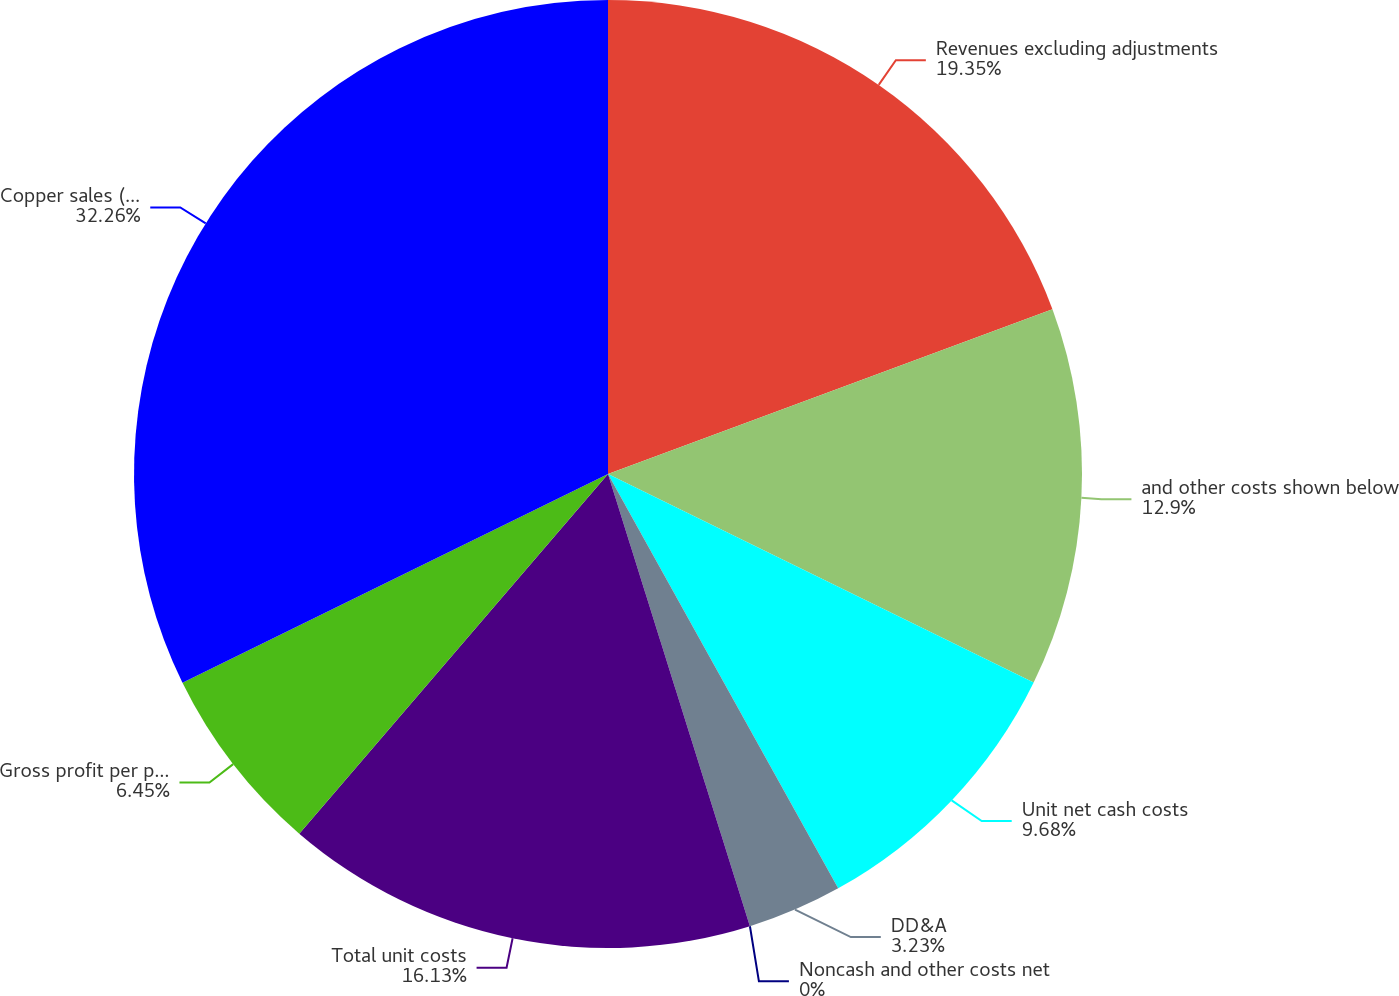Convert chart to OTSL. <chart><loc_0><loc_0><loc_500><loc_500><pie_chart><fcel>Revenues excluding adjustments<fcel>and other costs shown below<fcel>Unit net cash costs<fcel>DD&A<fcel>Noncash and other costs net<fcel>Total unit costs<fcel>Gross profit per pound<fcel>Copper sales (millions of<nl><fcel>19.35%<fcel>12.9%<fcel>9.68%<fcel>3.23%<fcel>0.0%<fcel>16.13%<fcel>6.45%<fcel>32.26%<nl></chart> 